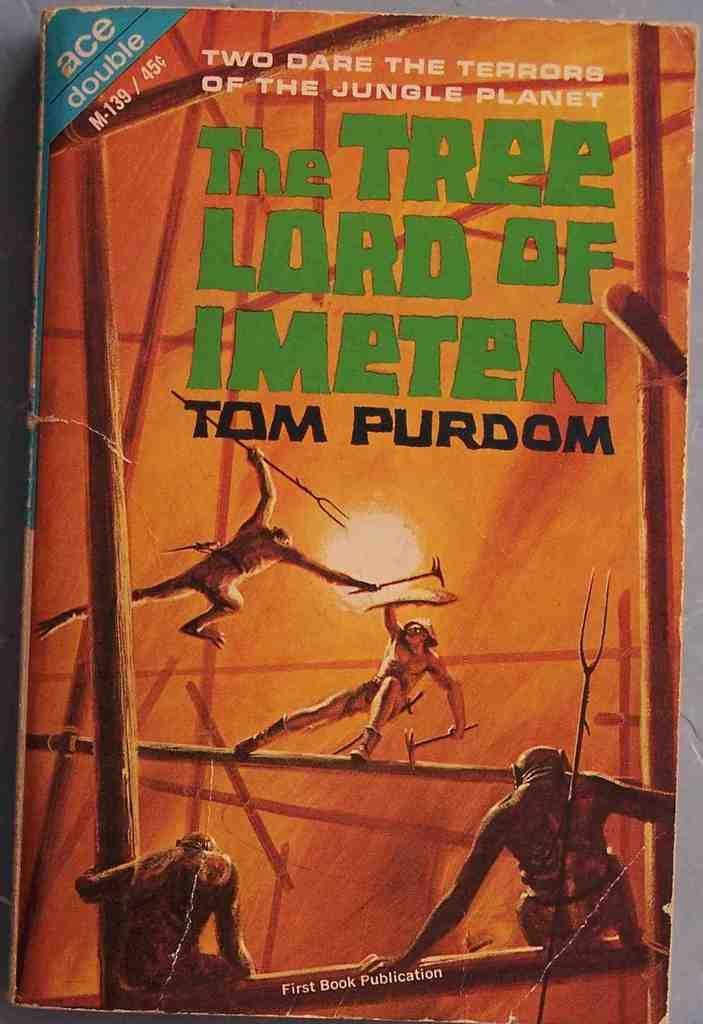Provide a one-sentence caption for the provided image. The cover of the book "The Tree Lord of Imeten" by Tom Purdom shows a man fighting apes. 